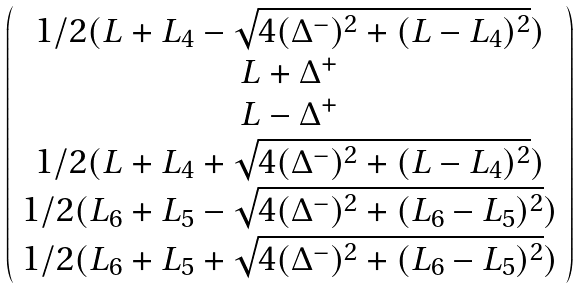<formula> <loc_0><loc_0><loc_500><loc_500>\left ( \begin{array} { c } 1 / 2 ( L + L _ { 4 } - \sqrt { 4 ( \Delta ^ { - } ) ^ { 2 } + ( L - L _ { 4 } ) ^ { 2 } } ) \\ L + \Delta ^ { + } \\ L - \Delta ^ { + } \\ 1 / 2 ( L + L _ { 4 } + \sqrt { 4 ( \Delta ^ { - } ) ^ { 2 } + ( L - L _ { 4 } ) ^ { 2 } } ) \\ 1 / 2 ( L _ { 6 } + L _ { 5 } - \sqrt { 4 ( \Delta ^ { - } ) ^ { 2 } + ( L _ { 6 } - L _ { 5 } ) ^ { 2 } } ) \\ 1 / 2 ( L _ { 6 } + L _ { 5 } + \sqrt { 4 ( \Delta ^ { - } ) ^ { 2 } + ( L _ { 6 } - L _ { 5 } ) ^ { 2 } } ) \end{array} \right )</formula> 